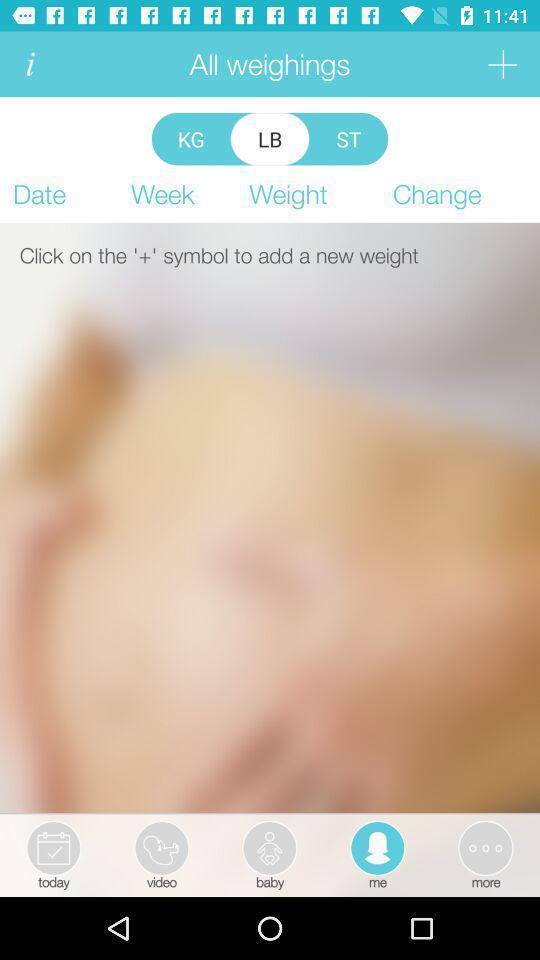Provide a detailed account of this screenshot. Page showing to add new weight. 